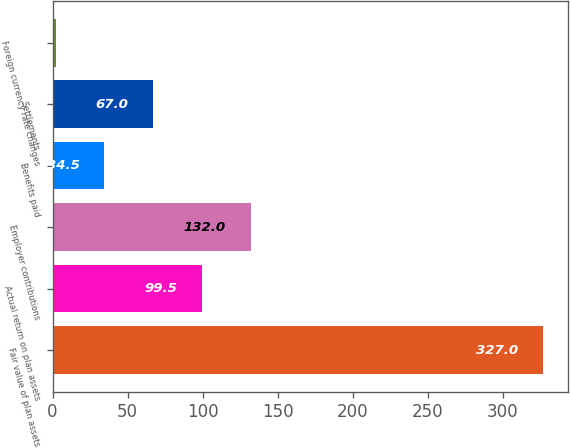Convert chart to OTSL. <chart><loc_0><loc_0><loc_500><loc_500><bar_chart><fcel>Fair value of plan assets<fcel>Actual return on plan assets<fcel>Employer contributions<fcel>Benefits paid<fcel>Settlements<fcel>Foreign currency rate changes<nl><fcel>327<fcel>99.5<fcel>132<fcel>34.5<fcel>67<fcel>2<nl></chart> 